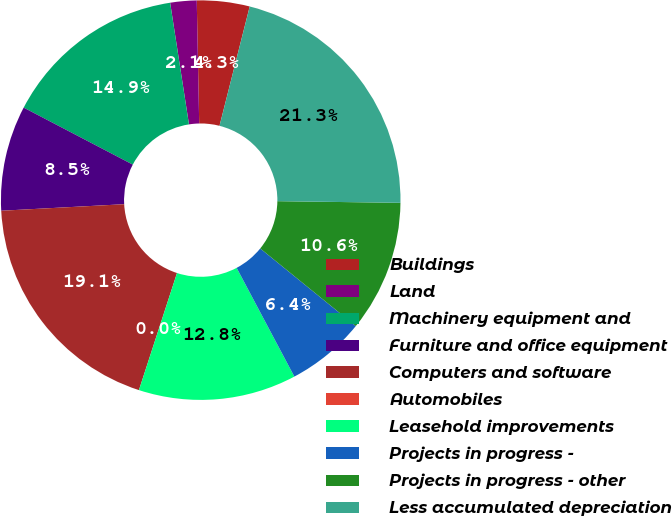Convert chart to OTSL. <chart><loc_0><loc_0><loc_500><loc_500><pie_chart><fcel>Buildings<fcel>Land<fcel>Machinery equipment and<fcel>Furniture and office equipment<fcel>Computers and software<fcel>Automobiles<fcel>Leasehold improvements<fcel>Projects in progress -<fcel>Projects in progress - other<fcel>Less accumulated depreciation<nl><fcel>4.26%<fcel>2.13%<fcel>14.89%<fcel>8.51%<fcel>19.15%<fcel>0.0%<fcel>12.77%<fcel>6.38%<fcel>10.64%<fcel>21.27%<nl></chart> 